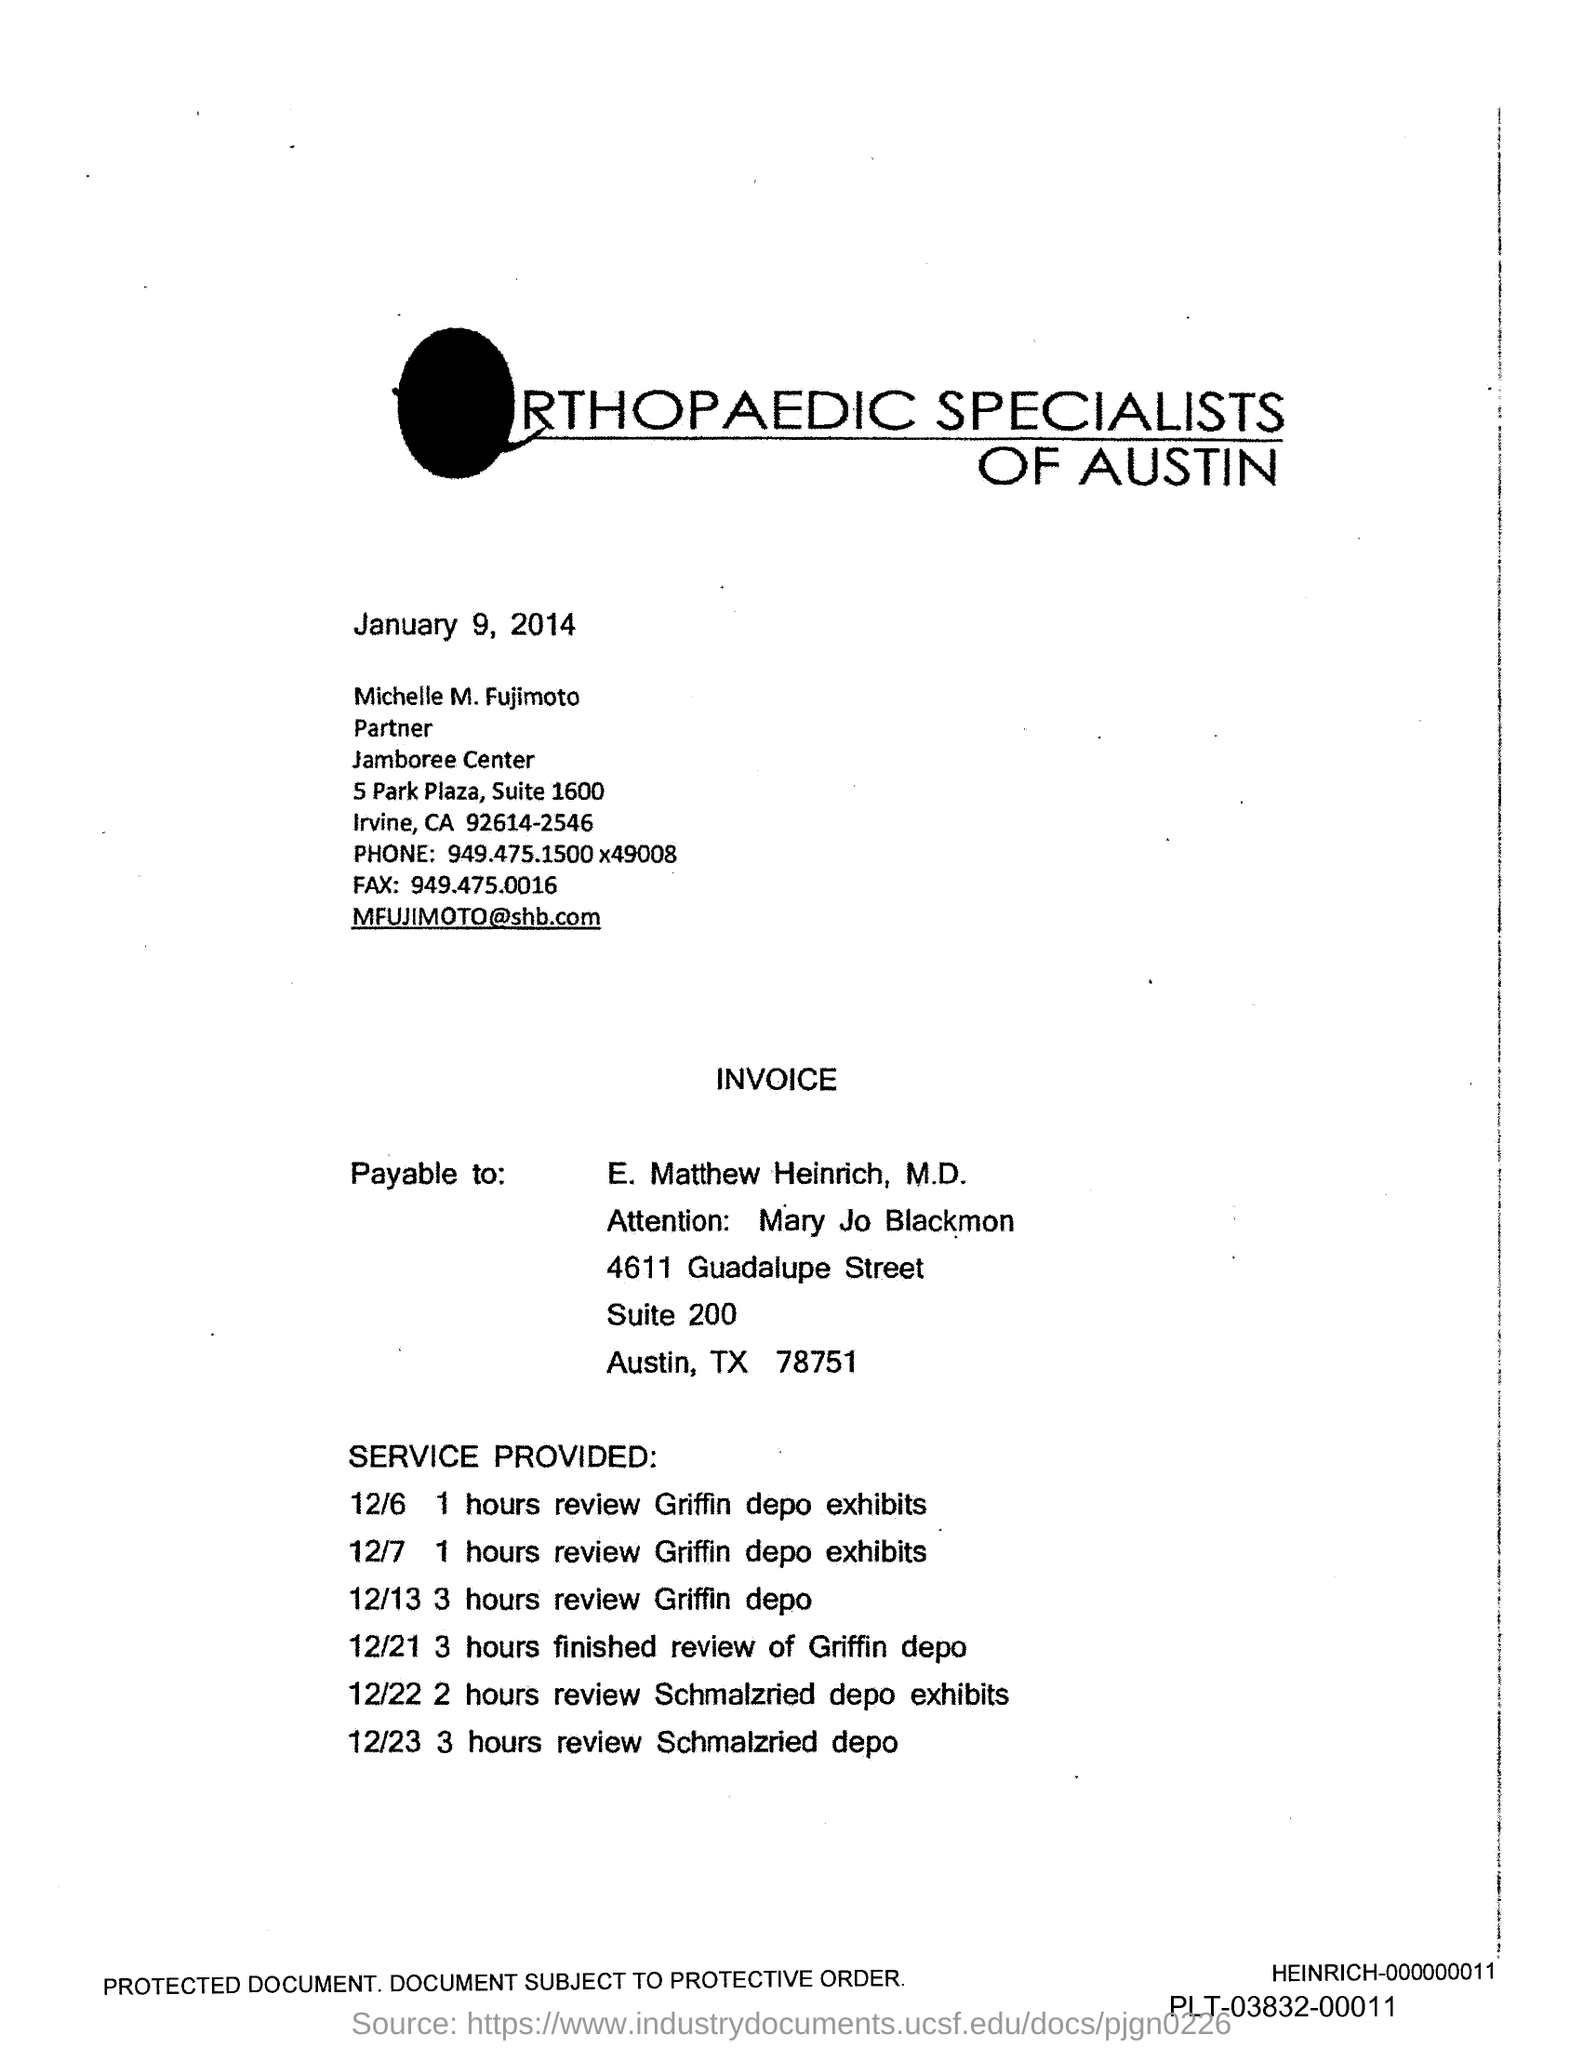Specify some key components in this picture. The fax number is 949.475.0016. 